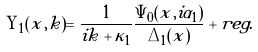<formula> <loc_0><loc_0><loc_500><loc_500>\Upsilon _ { 1 } ( x , k ) = \frac { 1 } { i k + \kappa _ { 1 } } \frac { \Psi _ { 0 } ( x , i \alpha _ { 1 } ) } { \Delta _ { 1 } ( x ) } + r e g .</formula> 